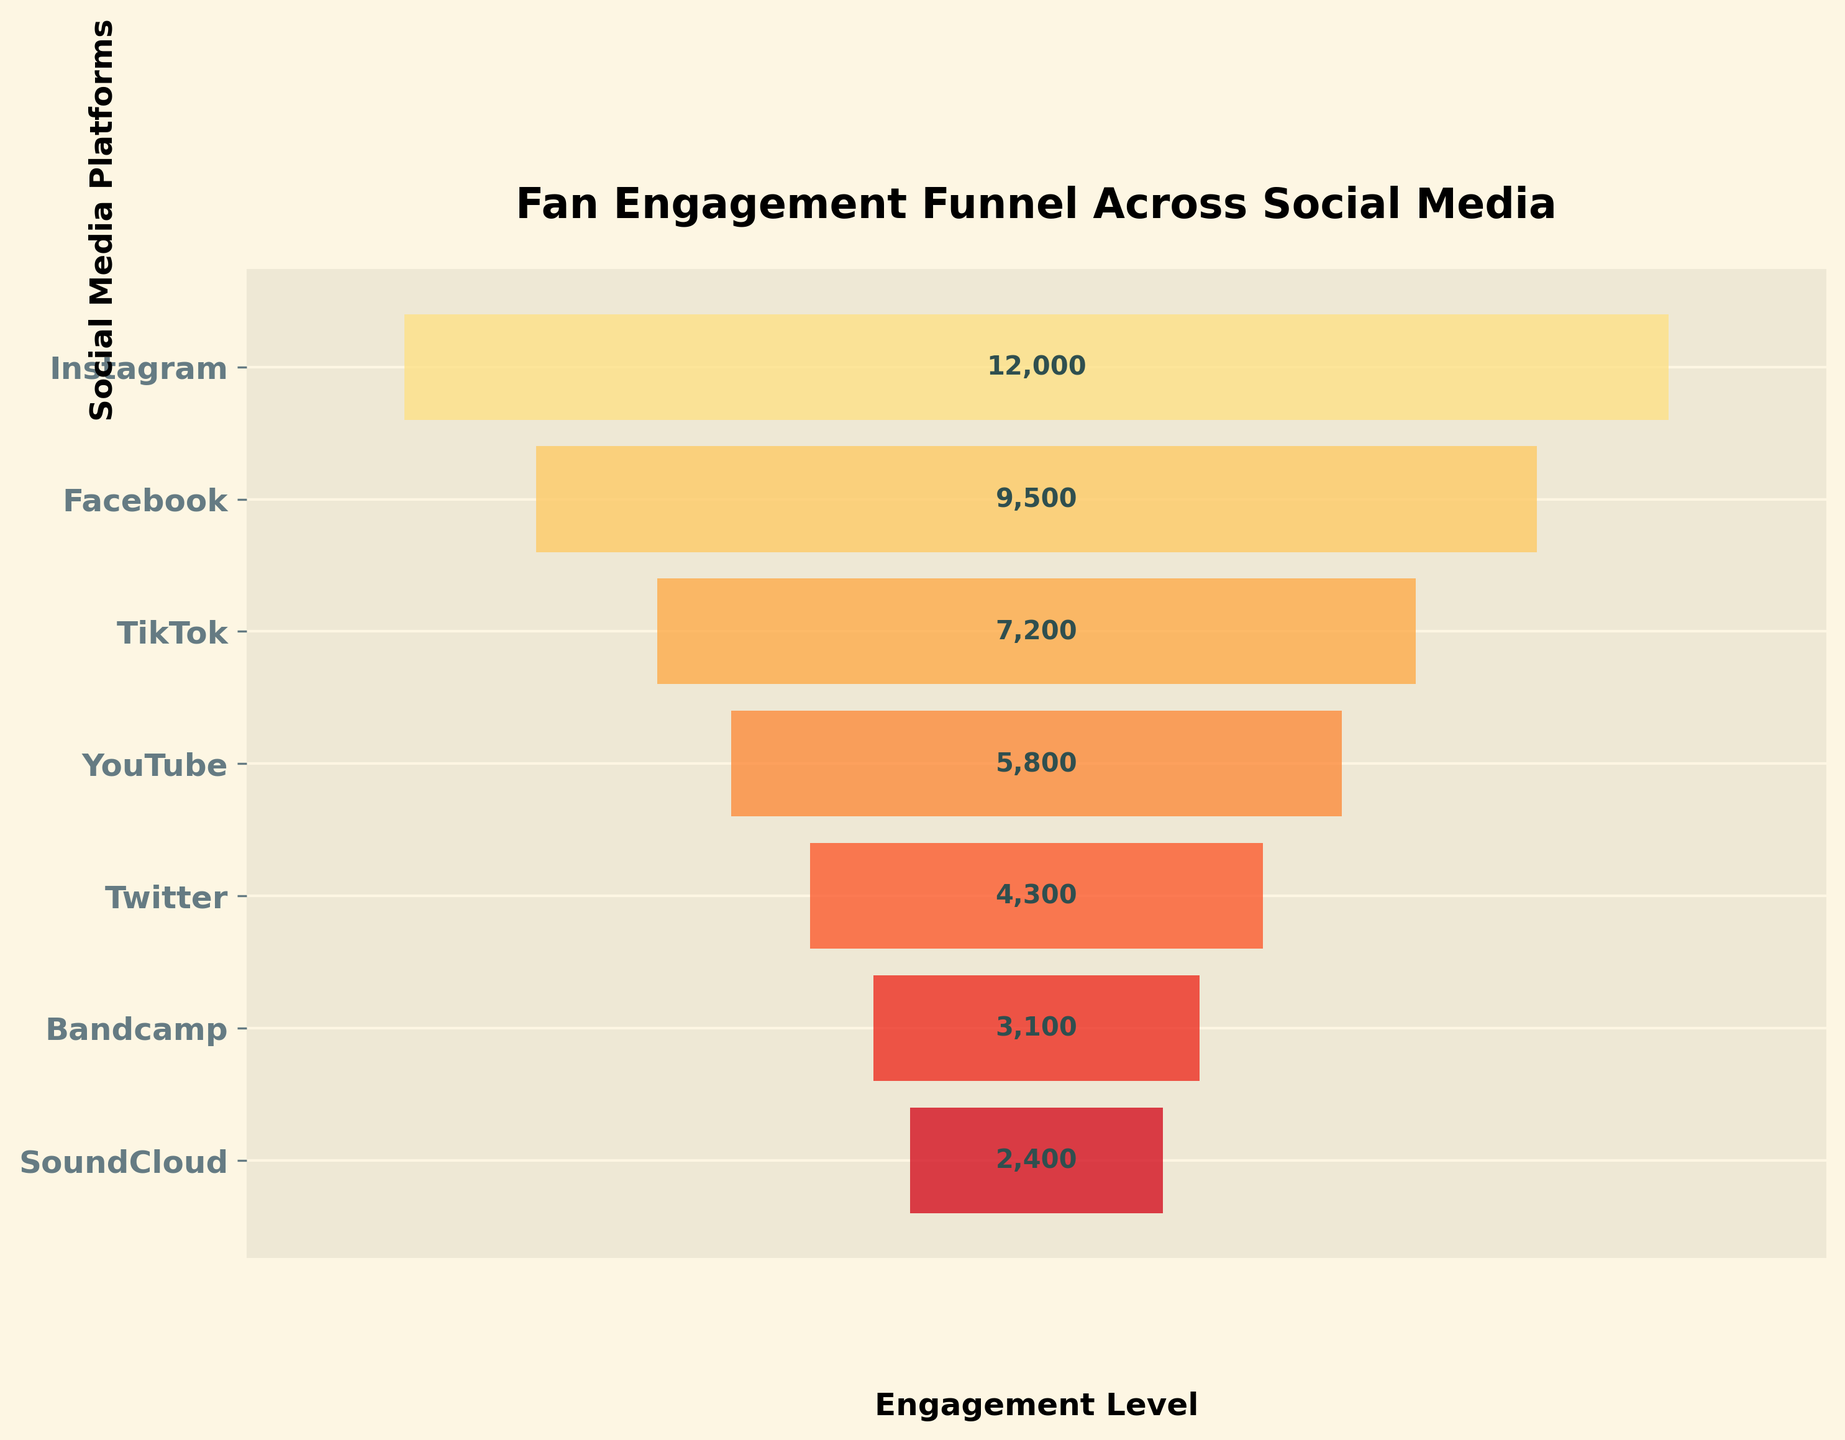Which platform has the highest engagement level? The platform with the highest bar reaching the furthest to the right has the highest engagement level. That platform is Instagram.
Answer: Instagram What is the title of the chart? The title is located at the top center of the chart and reads "Fan Engagement Funnel Across Social Media".
Answer: Fan Engagement Funnel Across Social Media How many social media platforms are represented in the funnel chart? Count the number of bars or labels along the y-axis, which represent different social media platforms. There are seven platforms listed.
Answer: 7 Which platform has lower engagement, YouTube or Facebook? Comparing the bars for YouTube and Facebook, the YouTube bar is shorter and does not reach as far to the right as Facebook’s bar, indicating lower engagement.
Answer: YouTube What is the engagement level for TikTok? The figure includes a text label indicating the engagement level next to each bar. The label for TikTok states 7,200.
Answer: 7,200 What is the total engagement level across all platforms? Sum the engagement levels for all platforms: 12,000 (Instagram) + 9,500 (Facebook) + 7,200 (TikTok) + 5,800 (YouTube) + 4,300 (Twitter) + 3,100 (Bandcamp) + 2,400 (SoundCloud) = 44,300.
Answer: 44,300 Which platform shows the least engagement? The platform with the shortest bar reaching the least to the right is SoundCloud.
Answer: SoundCloud What is the difference in engagement level between Instagram and Twitter? Subtract the engagement level of Twitter from Instagram: 12,000 (Instagram) - 4,300 (Twitter) = 7,700.
Answer: 7,700 By how much does Facebook's engagement level exceed SoundCloud's? Subtract the engagement level of SoundCloud from Facebook: 9,500 (Facebook) - 2,400 (SoundCloud) = 7,100.
Answer: 7,100 